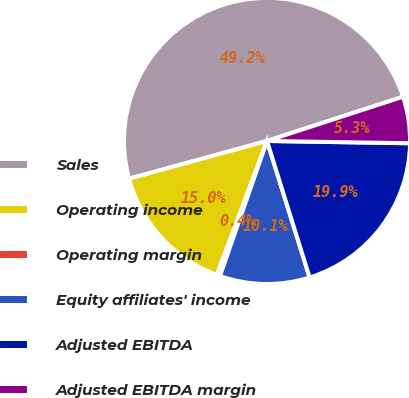Convert chart. <chart><loc_0><loc_0><loc_500><loc_500><pie_chart><fcel>Sales<fcel>Operating income<fcel>Operating margin<fcel>Equity affiliates' income<fcel>Adjusted EBITDA<fcel>Adjusted EBITDA margin<nl><fcel>49.25%<fcel>15.04%<fcel>0.37%<fcel>10.15%<fcel>19.93%<fcel>5.26%<nl></chart> 